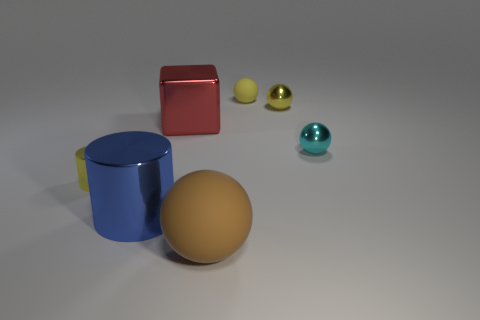Add 1 yellow metallic spheres. How many objects exist? 8 Subtract all cylinders. How many objects are left? 5 Add 2 small red metallic cylinders. How many small red metallic cylinders exist? 2 Subtract 0 green spheres. How many objects are left? 7 Subtract all large red things. Subtract all small metallic balls. How many objects are left? 4 Add 5 tiny cylinders. How many tiny cylinders are left? 6 